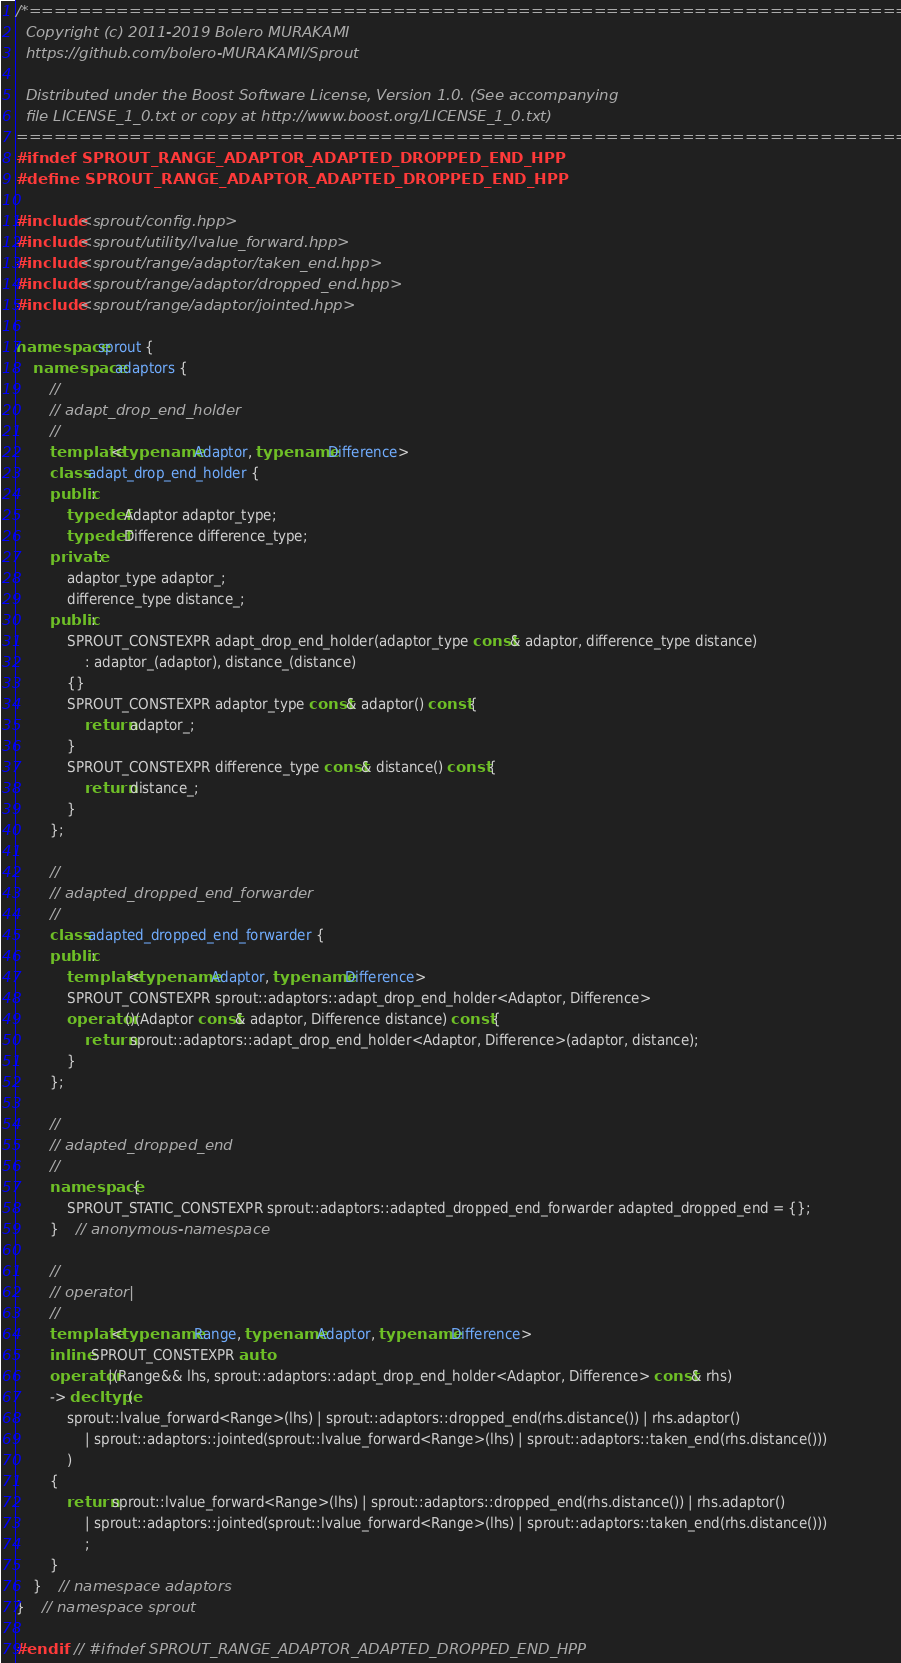<code> <loc_0><loc_0><loc_500><loc_500><_C++_>/*=============================================================================
  Copyright (c) 2011-2019 Bolero MURAKAMI
  https://github.com/bolero-MURAKAMI/Sprout

  Distributed under the Boost Software License, Version 1.0. (See accompanying
  file LICENSE_1_0.txt or copy at http://www.boost.org/LICENSE_1_0.txt)
=============================================================================*/
#ifndef SPROUT_RANGE_ADAPTOR_ADAPTED_DROPPED_END_HPP
#define SPROUT_RANGE_ADAPTOR_ADAPTED_DROPPED_END_HPP

#include <sprout/config.hpp>
#include <sprout/utility/lvalue_forward.hpp>
#include <sprout/range/adaptor/taken_end.hpp>
#include <sprout/range/adaptor/dropped_end.hpp>
#include <sprout/range/adaptor/jointed.hpp>

namespace sprout {
	namespace adaptors {
		//
		// adapt_drop_end_holder
		//
		template<typename Adaptor, typename Difference>
		class adapt_drop_end_holder {
		public:
			typedef Adaptor adaptor_type;
			typedef Difference difference_type;
		private:
			adaptor_type adaptor_;
			difference_type distance_;
		public:
			SPROUT_CONSTEXPR adapt_drop_end_holder(adaptor_type const& adaptor, difference_type distance)
				: adaptor_(adaptor), distance_(distance)
			{}
			SPROUT_CONSTEXPR adaptor_type const& adaptor() const {
				return adaptor_;
			}
			SPROUT_CONSTEXPR difference_type const& distance() const {
				return distance_;
			}
		};

		//
		// adapted_dropped_end_forwarder
		//
		class adapted_dropped_end_forwarder {
		public:
			template<typename Adaptor, typename Difference>
			SPROUT_CONSTEXPR sprout::adaptors::adapt_drop_end_holder<Adaptor, Difference>
			operator()(Adaptor const& adaptor, Difference distance) const {
				return sprout::adaptors::adapt_drop_end_holder<Adaptor, Difference>(adaptor, distance);
			}
		};

		//
		// adapted_dropped_end
		//
		namespace {
			SPROUT_STATIC_CONSTEXPR sprout::adaptors::adapted_dropped_end_forwarder adapted_dropped_end = {};
		}	// anonymous-namespace

		//
		// operator|
		//
		template<typename Range, typename Adaptor, typename Difference>
		inline SPROUT_CONSTEXPR auto
		operator|(Range&& lhs, sprout::adaptors::adapt_drop_end_holder<Adaptor, Difference> const& rhs)
		-> decltype(
			sprout::lvalue_forward<Range>(lhs) | sprout::adaptors::dropped_end(rhs.distance()) | rhs.adaptor()
				| sprout::adaptors::jointed(sprout::lvalue_forward<Range>(lhs) | sprout::adaptors::taken_end(rhs.distance()))
			)
		{
			return sprout::lvalue_forward<Range>(lhs) | sprout::adaptors::dropped_end(rhs.distance()) | rhs.adaptor()
				| sprout::adaptors::jointed(sprout::lvalue_forward<Range>(lhs) | sprout::adaptors::taken_end(rhs.distance()))
				;
		}
	}	// namespace adaptors
}	// namespace sprout

#endif	// #ifndef SPROUT_RANGE_ADAPTOR_ADAPTED_DROPPED_END_HPP
</code> 